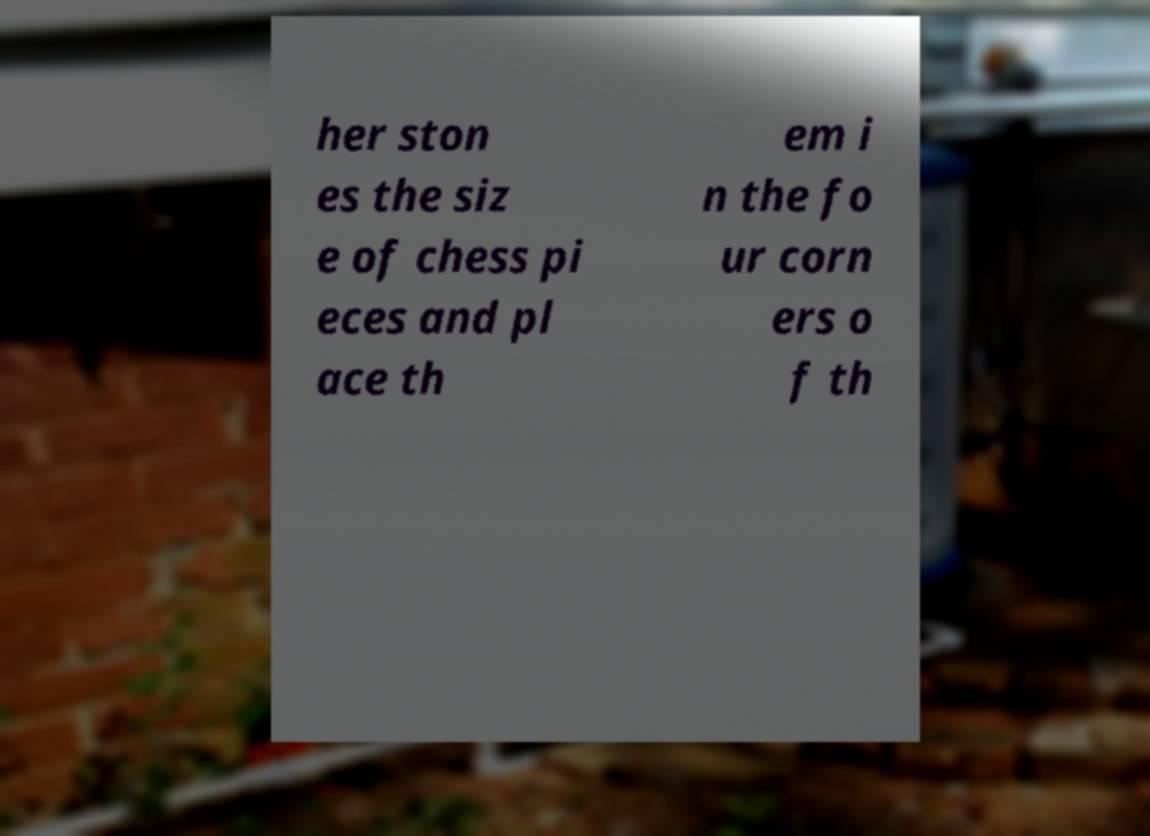Please read and relay the text visible in this image. What does it say? her ston es the siz e of chess pi eces and pl ace th em i n the fo ur corn ers o f th 